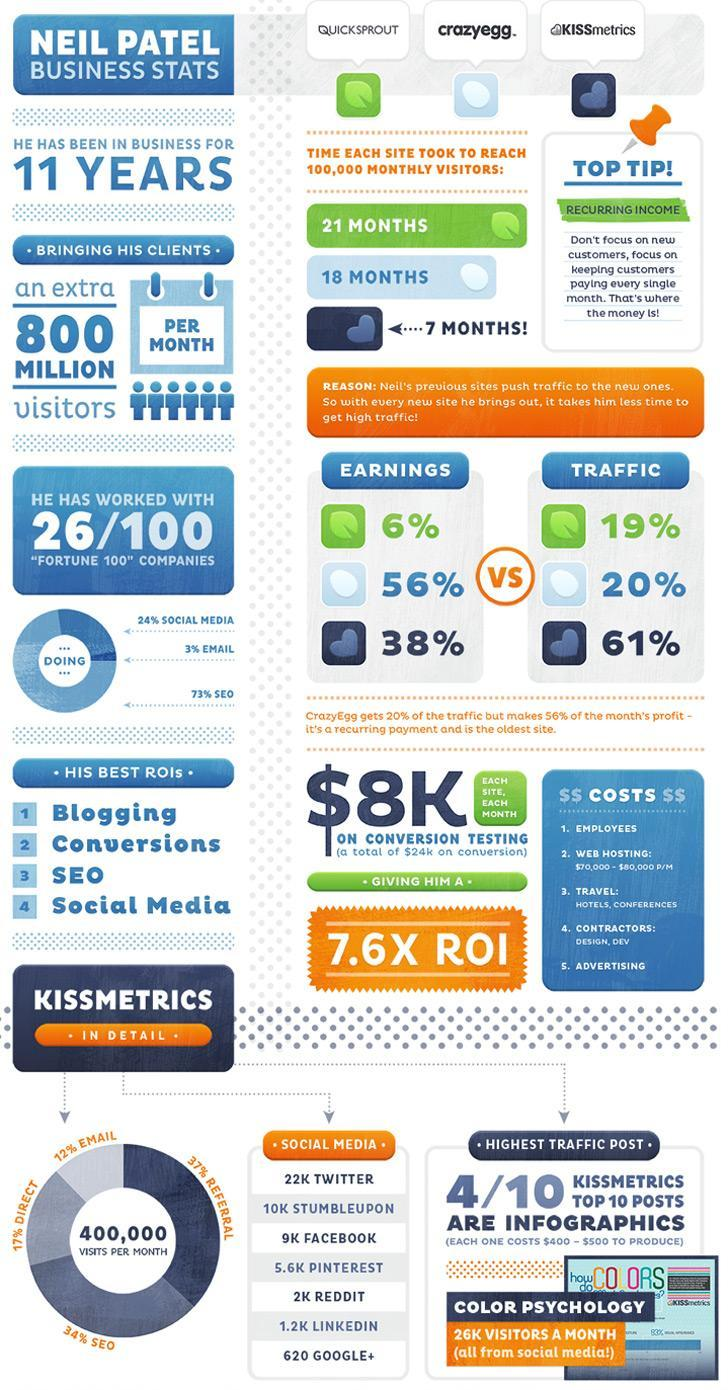What time did Quicksprout take to reach 100,000 monthly visitors?
Answer the question with a short phrase. 21 months What time did Kissmetrics take to reach 100,000 monthly visitors? 7 months What Percentage of people use Search Engine optimization in Kissmetrics? 34% Where does he get his third best Return of investment from? SEO Where does he get his fourth best Return of investment from? Social Media What time did Crazyegg take to reach 100,000 monthly visitors? 18 months 